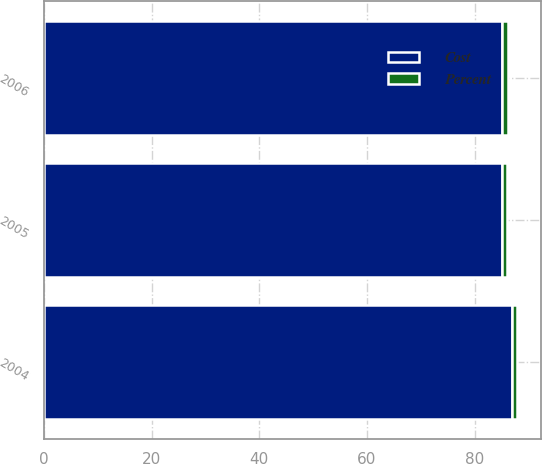<chart> <loc_0><loc_0><loc_500><loc_500><stacked_bar_chart><ecel><fcel>2006<fcel>2005<fcel>2004<nl><fcel>Percent<fcel>1.24<fcel>1.01<fcel>0.89<nl><fcel>Cost<fcel>85<fcel>85<fcel>87<nl></chart> 